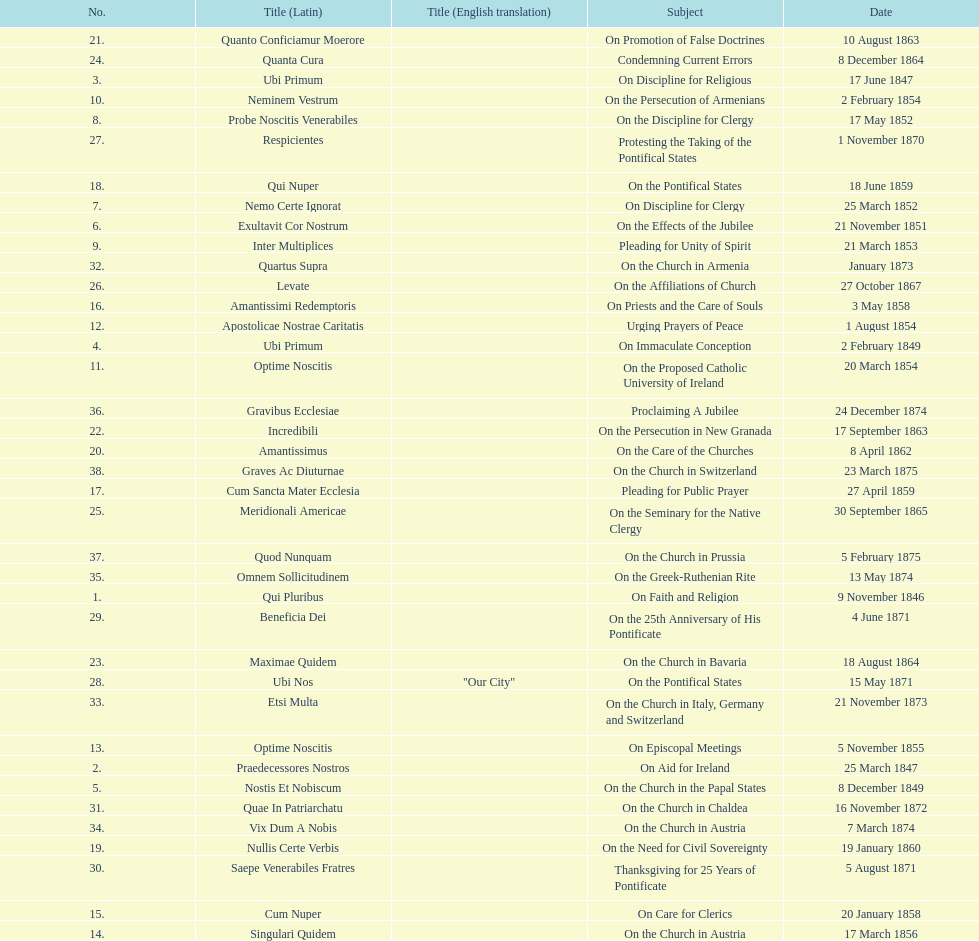Total number of encyclicals on churches . 11. 